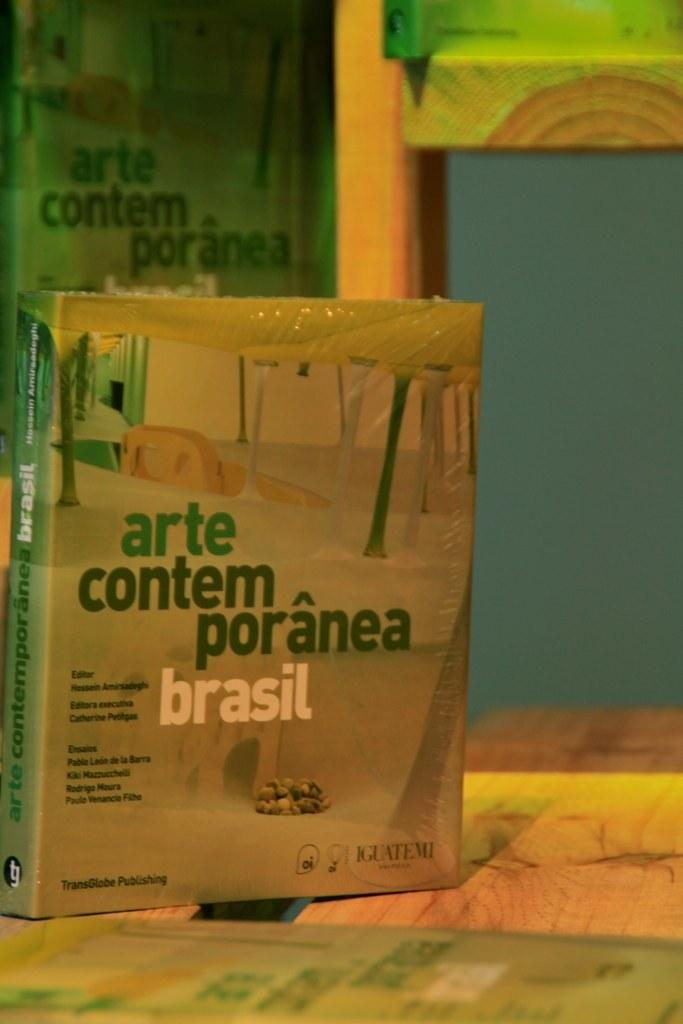<image>
Present a compact description of the photo's key features. A book titled arte contem pranea is on a wooden table 